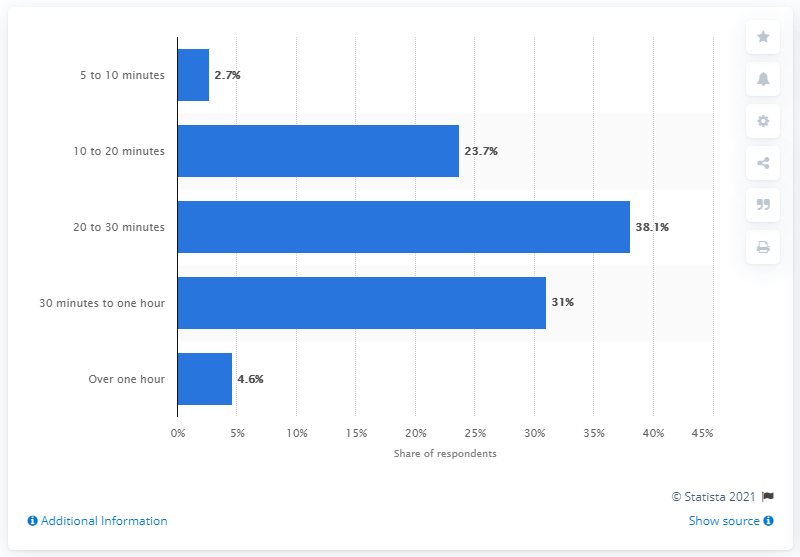Mention a couple of crucial points in this snapshot. According to a survey, 38.1% of Canadians stated that they typically spend between 20 and 30 minutes in grocery stores per visit. 